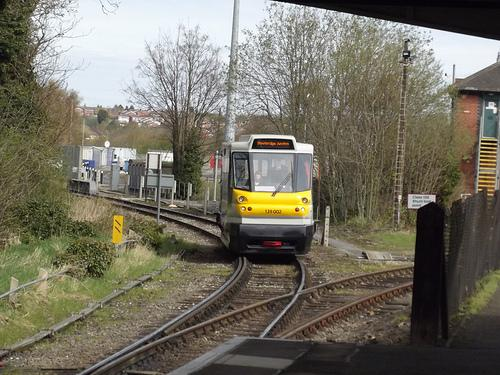What type of transportation can be seen in the image? There is a train on the tracks in the image. Describe any visible details on the train itself. The train has a windshield with a wiper, a yellow front, electronic destination sign, lights on the front, and an engineer inside. Enumerate the various objects near or around the train tracks. Grass, a building, a fence, a sign, trees, and a junction warning sign are all near the train tracks. What is the primary color of the train? The train is yellow and white. What type of fence is present next to the tracks? There is a well-worn wooden fence next to the tracks. Elaborate the details of the train tracks shown in the image. There are two sets of intersecting, curved railroad tracks with gravel in between and a junction warning sign nearby. Describe the different objects and their interactions within the image. A white and yellow train is on the tracks, which pass through a grassy area with a wooden fence, a building nearby, and a sign next to it. Trees and buildings are in the background, with utility buildings in the distance. What do the words on the train communicate? The words on the train show the rail car destination. List the objects that can be seen behind or in the background of the train. Behind the train, there are trees, buildings, utility buildings, blue sky, and cloud cover. Mention any distinctive features about the building present in the image. The building has yellow stairs, a second-floor door, and is located next to a sign. Identify any details about the sign showing rail car destination in the image. It is an electronic sign showing rail car destination, with orange words on the display. What color is the sky in the distance? Blue In the image provided, can you determine if there are any stairs in the buildings? Yes, a building has stairs and a yellow stairway leading to a second-floor door. What type of sign is next to the building? A white informational sign What is unusual about the cloud cover in the image? Nothing unusual about the cloud cover, it's just a daytime sky with some clouds. Is there any specific feature on the train's windshield? Yes, there is a wiper on the train's windshield. Is there any object leaning against something in the scene? If so, describe it. Yes, a ladder is leaning against a utility pole. Are there any words or text visible in the image? Please describe them. Yes, there are orange words on a display, indicating an electronic destination sign. Which of the following options best describes any noticeable tracks in the image: A) Train tracks on the ground B) Footprints in the grass C) Tire tracks on the gravel A) Train tracks on the ground Are there any trains on a set of curved railroad tracks in the image? Yes Describe the junction near the train tracks. Railroad track line junction with two sets of intersecting tracks List the objects that are located next to the tracks in the image. Grass, wooden fence, yellow junction warning sign, and gravel Analyze the multi-modal image and create a song lyric that highlights the scene. "Riding on a yellow train, cruising down the track, passing by some trees and grass, and the buildings in the back." Referencing the image, can you infer if there is an event happening that involves any emotions? No, there is no such event. Based on the image, describe the scene with the train and its surroundings. A yellow and white train is on tracks with a building, trees, and a fence nearby. There is grass, gravel, and a junction warning sign next to the tracks. A rail car destination sign and an engineer can be seen near the train. Describe the appearance of the trees near the train. Trees are leafy and a few branches without leaves can be seen. What color is the train in the image? Yellow and white Identify and describe the type of fence near the train tracks. Well-worn wooden fence 